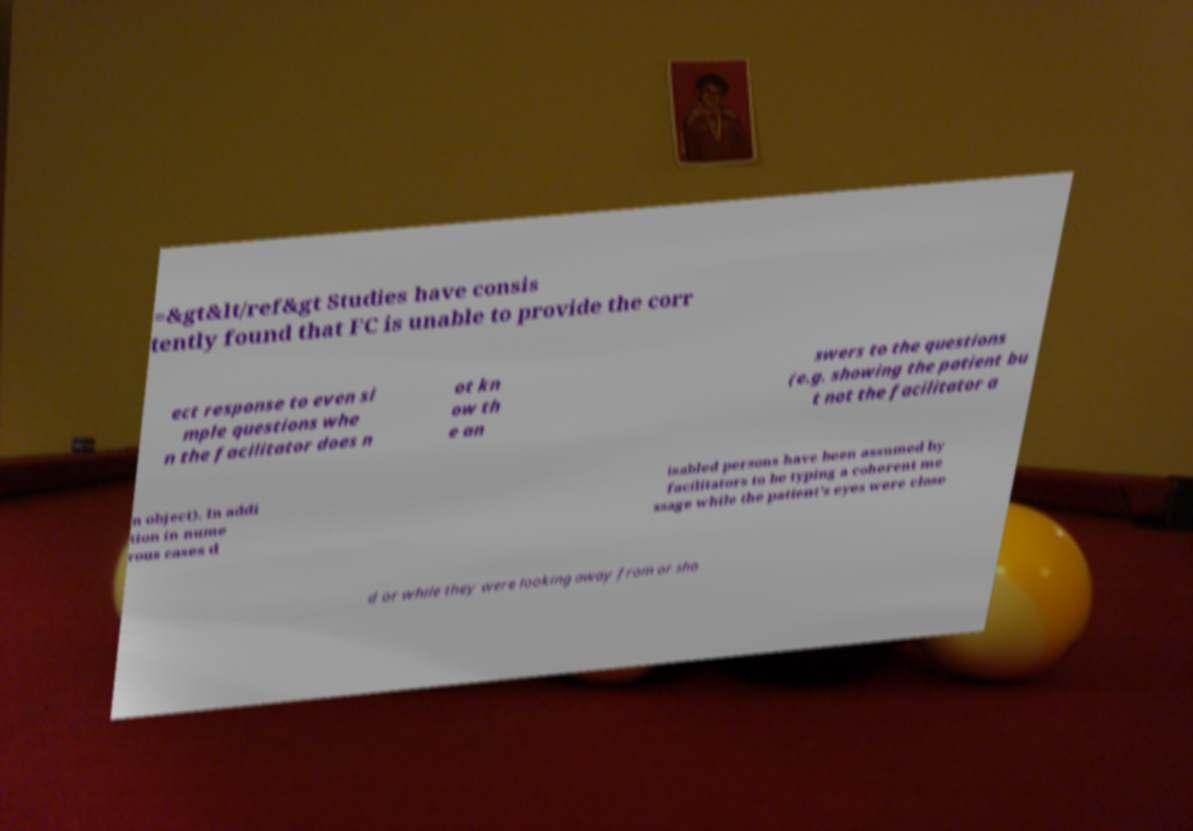There's text embedded in this image that I need extracted. Can you transcribe it verbatim? =&gt&lt/ref&gt Studies have consis tently found that FC is unable to provide the corr ect response to even si mple questions whe n the facilitator does n ot kn ow th e an swers to the questions (e.g. showing the patient bu t not the facilitator a n object). In addi tion in nume rous cases d isabled persons have been assumed by facilitators to be typing a coherent me ssage while the patient's eyes were close d or while they were looking away from or sho 